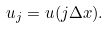<formula> <loc_0><loc_0><loc_500><loc_500>u _ { j } = u ( j \Delta x ) .</formula> 